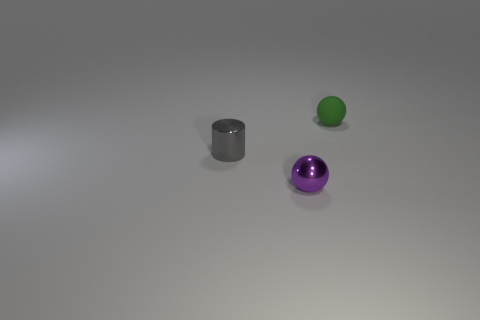Add 2 big red matte cubes. How many objects exist? 5 Subtract all cylinders. How many objects are left? 2 Add 1 gray cylinders. How many gray cylinders are left? 2 Add 1 brown rubber things. How many brown rubber things exist? 1 Subtract 0 green cylinders. How many objects are left? 3 Subtract all metallic spheres. Subtract all green things. How many objects are left? 1 